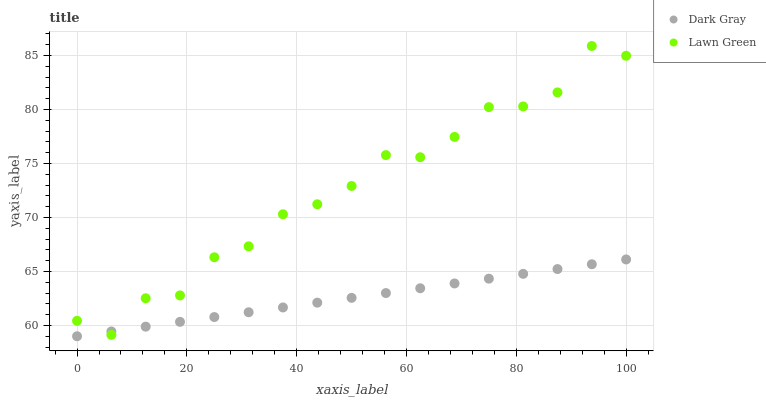Does Dark Gray have the minimum area under the curve?
Answer yes or no. Yes. Does Lawn Green have the maximum area under the curve?
Answer yes or no. Yes. Does Lawn Green have the minimum area under the curve?
Answer yes or no. No. Is Dark Gray the smoothest?
Answer yes or no. Yes. Is Lawn Green the roughest?
Answer yes or no. Yes. Is Lawn Green the smoothest?
Answer yes or no. No. Does Dark Gray have the lowest value?
Answer yes or no. Yes. Does Lawn Green have the lowest value?
Answer yes or no. No. Does Lawn Green have the highest value?
Answer yes or no. Yes. Does Dark Gray intersect Lawn Green?
Answer yes or no. Yes. Is Dark Gray less than Lawn Green?
Answer yes or no. No. Is Dark Gray greater than Lawn Green?
Answer yes or no. No. 